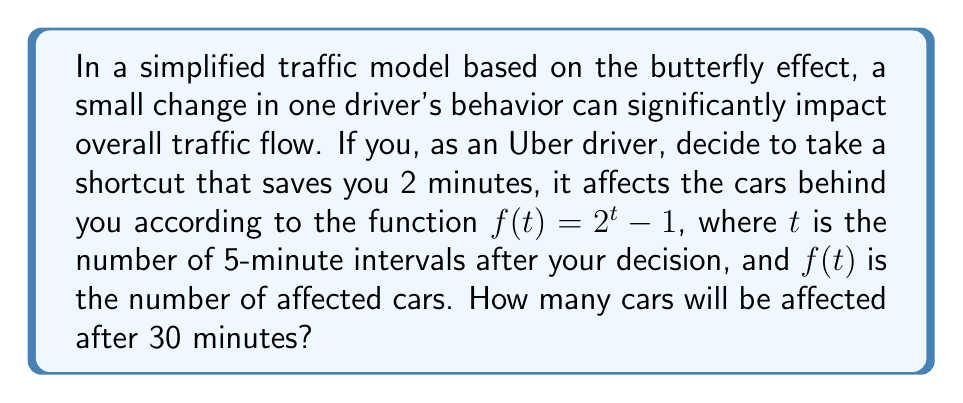Can you solve this math problem? Let's approach this step-by-step:

1) First, we need to determine how many 5-minute intervals are in 30 minutes:
   $30 \div 5 = 6$ intervals

2) Now, we can use the given function $f(t) = 2^t - 1$, where $t = 6$:

   $f(6) = 2^6 - 1$

3) Let's calculate $2^6$:
   $2^6 = 2 \times 2 \times 2 \times 2 \times 2 \times 2 = 64$

4) Now we can complete the calculation:
   $f(6) = 64 - 1 = 63$

Therefore, after 30 minutes (6 intervals of 5 minutes each), 63 cars will be affected by your initial 2-minute shortcut decision.

This exemplifies the butterfly effect in traffic patterns, where a small initial change can lead to significant consequences over time.
Answer: 63 cars 